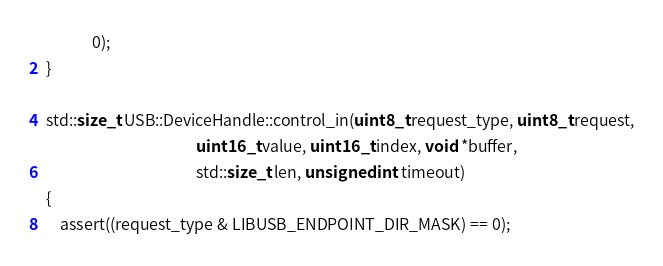<code> <loc_0><loc_0><loc_500><loc_500><_C++_>             0);
}

std::size_t USB::DeviceHandle::control_in(uint8_t request_type, uint8_t request,
                                          uint16_t value, uint16_t index, void *buffer,
                                          std::size_t len, unsigned int timeout)
{
    assert((request_type & LIBUSB_ENDPOINT_DIR_MASK) == 0);</code> 